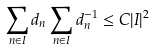<formula> <loc_0><loc_0><loc_500><loc_500>\sum _ { n \in I } d _ { n } \sum _ { n \in I } d _ { n } ^ { - 1 } \leq C | I | ^ { 2 }</formula> 